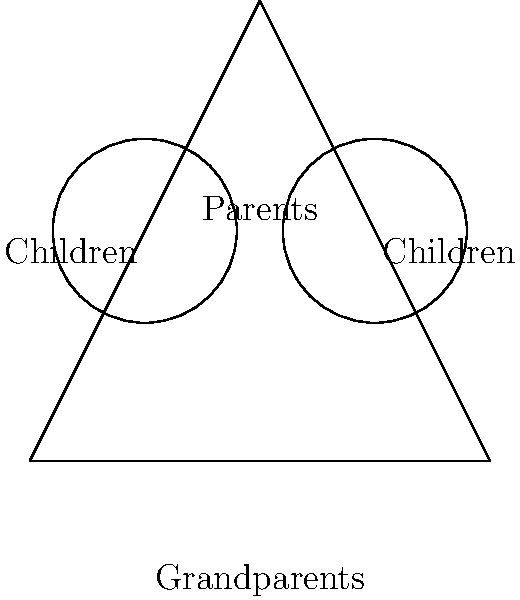In your family tree diagram, you've represented generations using congruent circles. If the circle representing your generation has a radius of 20 units, and the area of the circle representing your parents' generation is 2500π square units, how many times larger is the radius of your parents' circle compared to yours? Let's approach this step-by-step:

1) We know that the radius of your generation's circle is 20 units.

2) The area of your parents' generation circle is given as 2500π square units.

3) Recall the formula for the area of a circle: $A = \pi r^2$

4) We can use this to find the radius of your parents' circle:
   $2500\pi = \pi r^2$
   $2500 = r^2$
   $r = \sqrt{2500} = 50$

5) So, the radius of your parents' circle is 50 units.

6) To find how many times larger this is compared to your circle:
   $\frac{50}{20} = 2.5$

Therefore, the radius of your parents' circle is 2.5 times larger than yours.
Answer: 2.5 times 